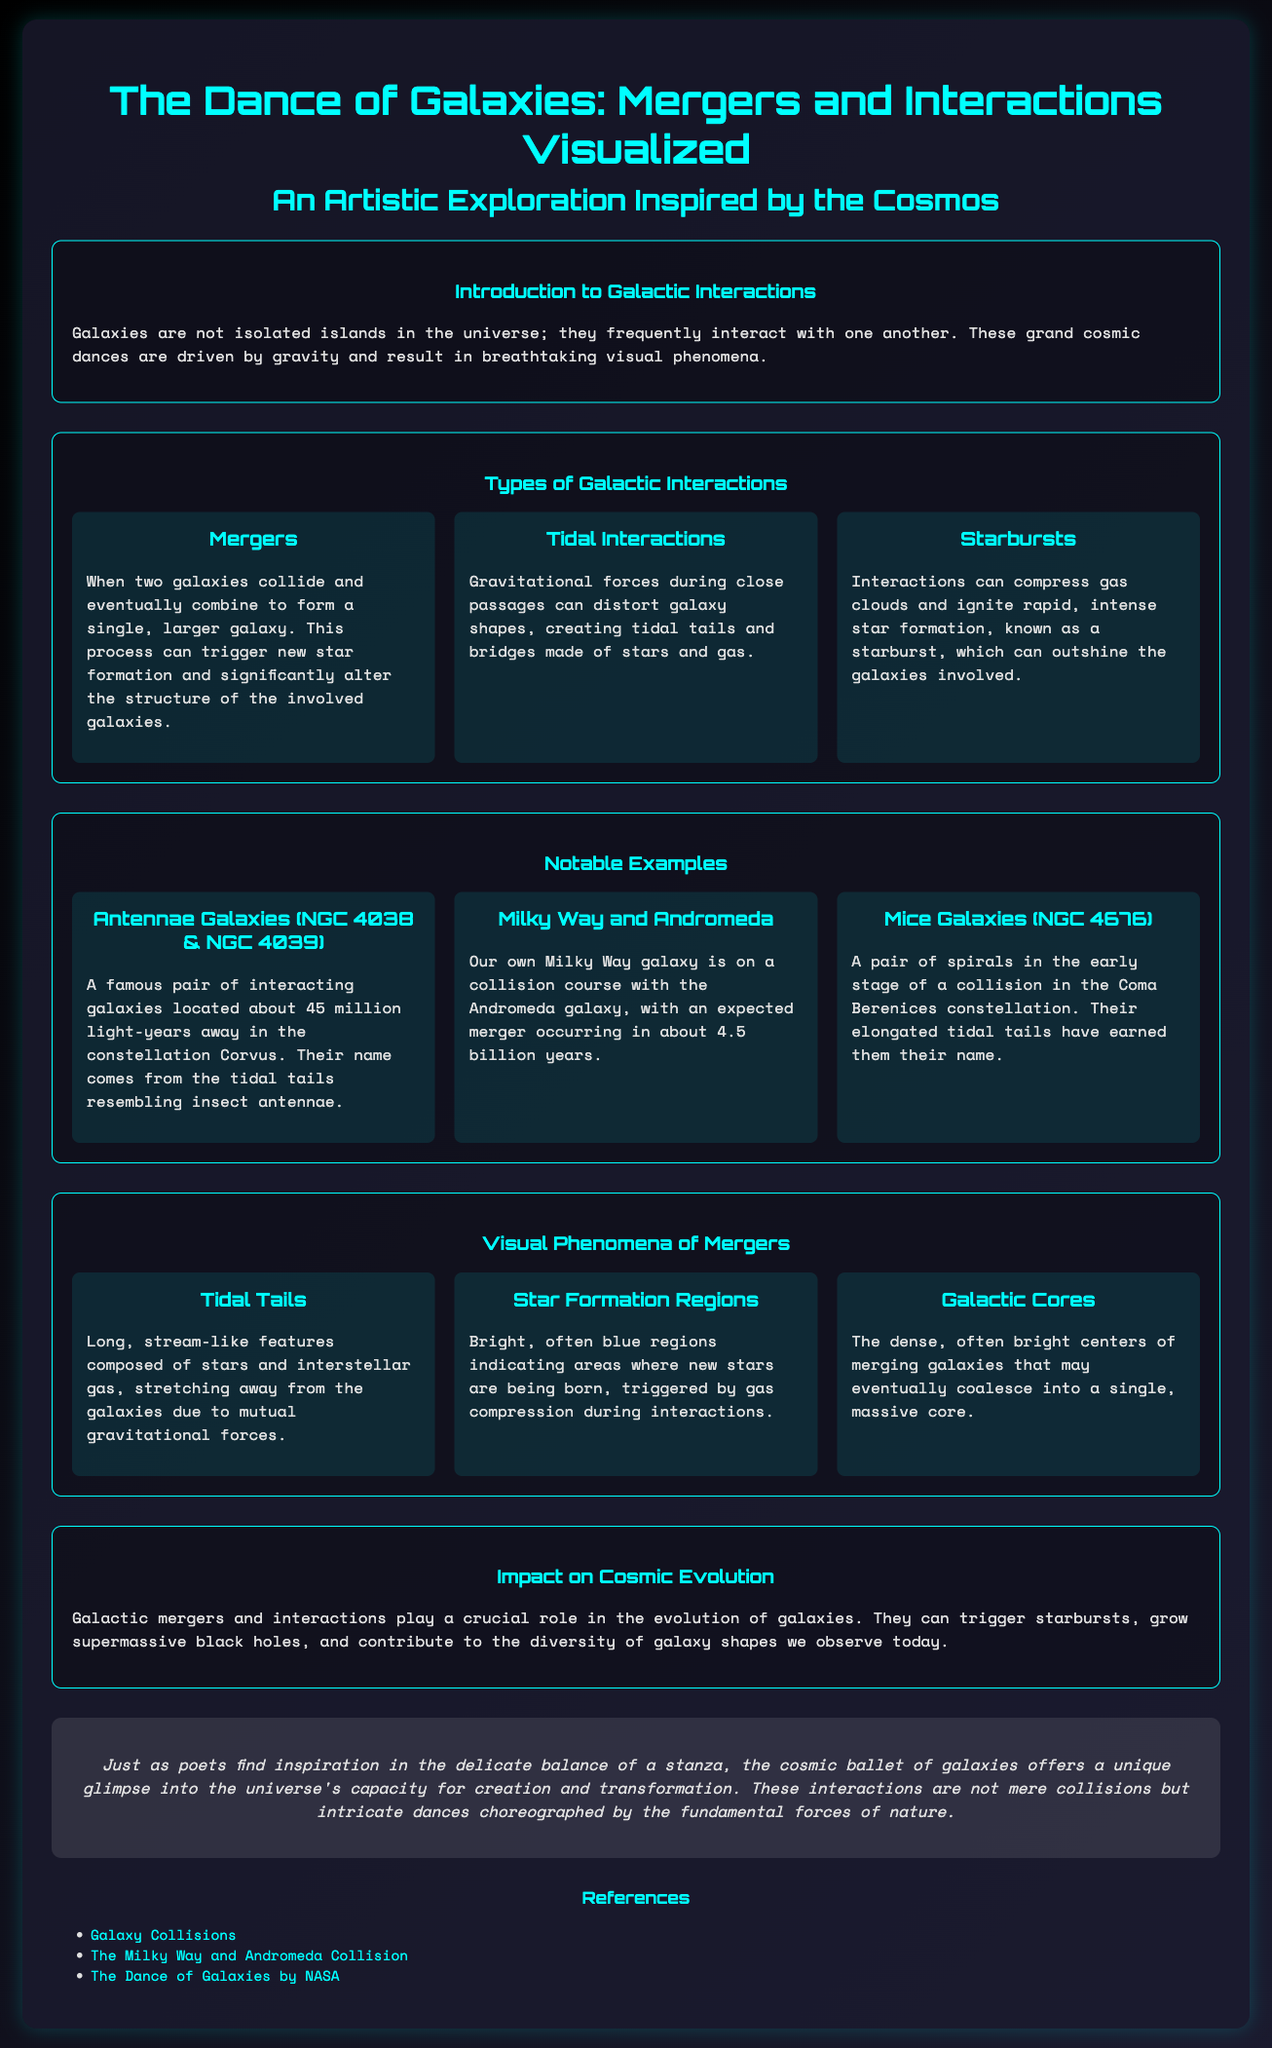What is the title of the infographic? The title is prominently displayed at the top of the document, highlighting the main theme.
Answer: The Dance of Galaxies: Mergers and Interactions Visualized How far away are the Antennae Galaxies? This distance is noted in the description of the Antennae Galaxies section, emphasizing their location in the cosmos.
Answer: 45 million light-years What process can trigger new star formation during galactic mergers? The document explains that mergers can dramatically change the involved galaxies and lead to new star formation.
Answer: Mergers What are the Mice Galaxies also known as? The name given to this pair of galaxies is mentioned, reflecting their physical appearance during their interaction.
Answer: NGC 4676 What type of galactic interaction can create tidal tails? This concept is discussed in detail, highlighting a specific visual phenomenon resulting from gravity during interactions.
Answer: Tidal Interactions What role do galactic mergers play in cosmic evolution? The infographic summarizes the significance of these events in the changing landscape of galaxies.
Answer: Crucial role Which galaxies are on a collision course? The text specifies the names of the galaxies involved in this future interaction, pointing to our own galactic neighborhood.
Answer: Milky Way and Andromeda What is the background theme of the infographic? This is stated in the introductory section, capturing the artistic inspiration behind the infographic.
Answer: An Artistic Exploration Inspired by the Cosmos 